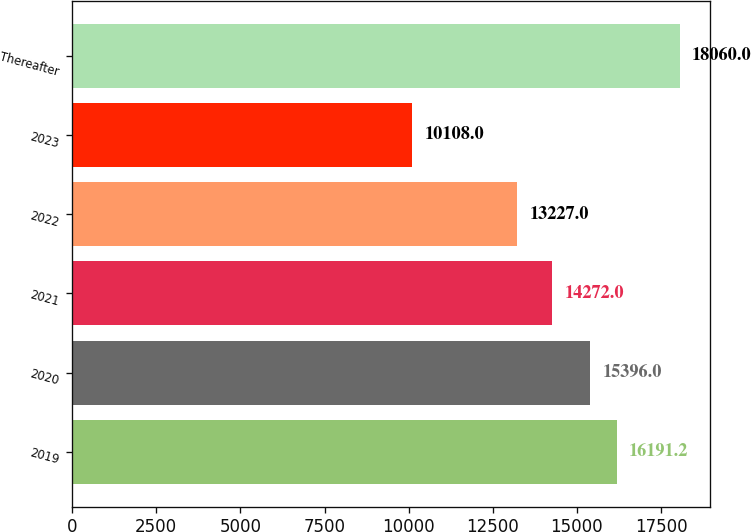<chart> <loc_0><loc_0><loc_500><loc_500><bar_chart><fcel>2019<fcel>2020<fcel>2021<fcel>2022<fcel>2023<fcel>Thereafter<nl><fcel>16191.2<fcel>15396<fcel>14272<fcel>13227<fcel>10108<fcel>18060<nl></chart> 